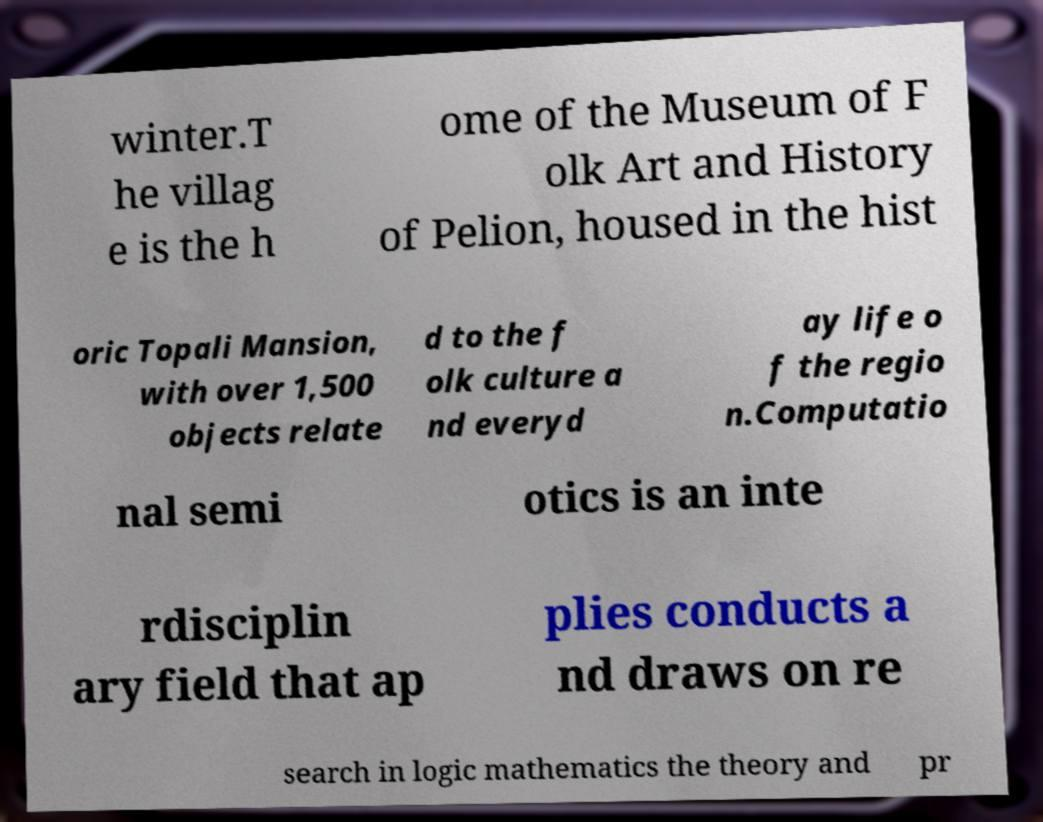Can you read and provide the text displayed in the image?This photo seems to have some interesting text. Can you extract and type it out for me? winter.T he villag e is the h ome of the Museum of F olk Art and History of Pelion, housed in the hist oric Topali Mansion, with over 1,500 objects relate d to the f olk culture a nd everyd ay life o f the regio n.Computatio nal semi otics is an inte rdisciplin ary field that ap plies conducts a nd draws on re search in logic mathematics the theory and pr 